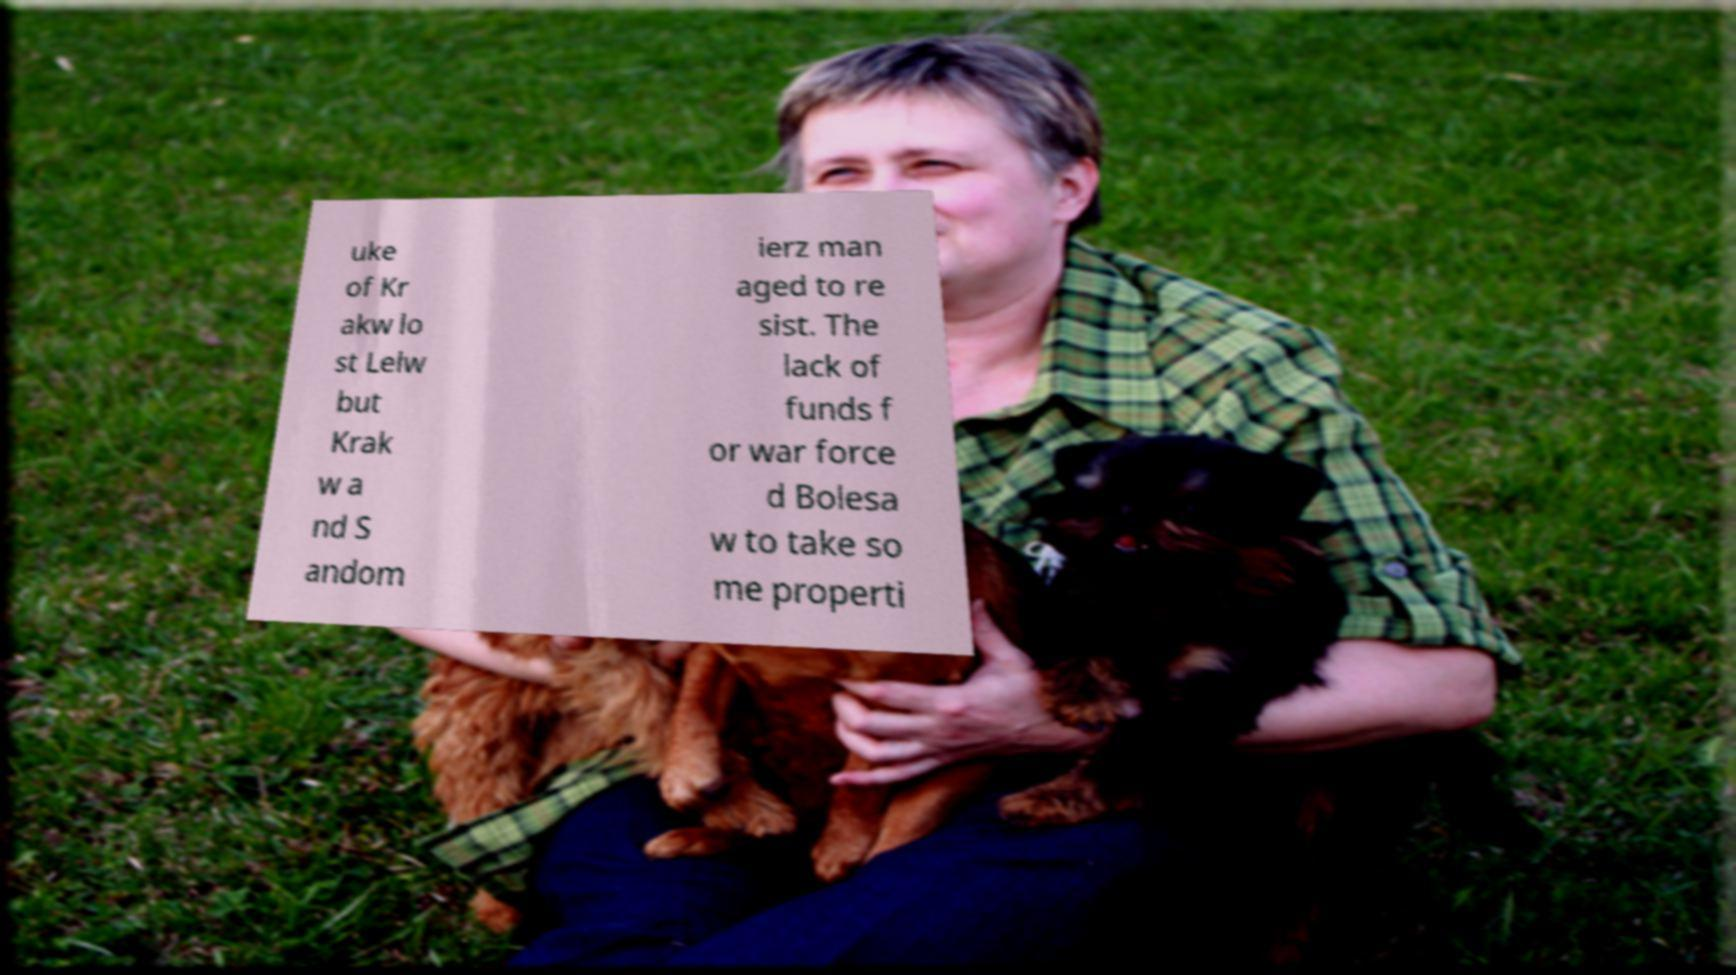What messages or text are displayed in this image? I need them in a readable, typed format. uke of Kr akw lo st Lelw but Krak w a nd S andom ierz man aged to re sist. The lack of funds f or war force d Bolesa w to take so me properti 